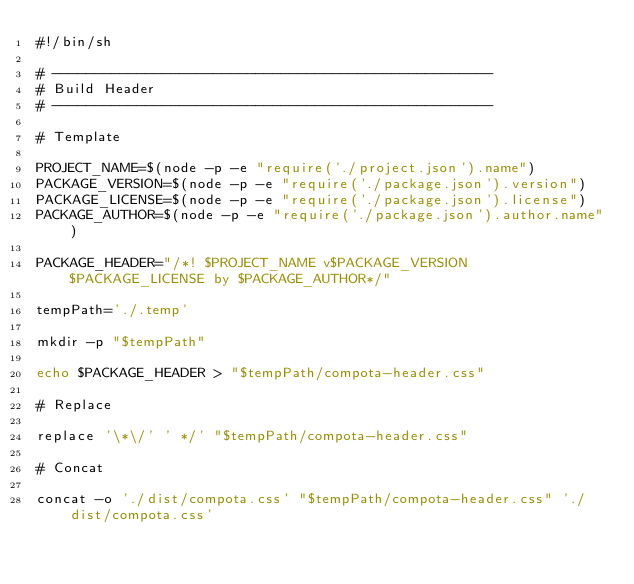<code> <loc_0><loc_0><loc_500><loc_500><_Bash_>#!/bin/sh

# ----------------------------------------------------
# Build Header
# ----------------------------------------------------

# Template

PROJECT_NAME=$(node -p -e "require('./project.json').name")
PACKAGE_VERSION=$(node -p -e "require('./package.json').version")
PACKAGE_LICENSE=$(node -p -e "require('./package.json').license")
PACKAGE_AUTHOR=$(node -p -e "require('./package.json').author.name")

PACKAGE_HEADER="/*! $PROJECT_NAME v$PACKAGE_VERSION $PACKAGE_LICENSE by $PACKAGE_AUTHOR*/"

tempPath='./.temp'

mkdir -p "$tempPath"

echo $PACKAGE_HEADER > "$tempPath/compota-header.css"

# Replace

replace '\*\/' ' */' "$tempPath/compota-header.css"

# Concat

concat -o './dist/compota.css' "$tempPath/compota-header.css" './dist/compota.css'</code> 